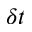<formula> <loc_0><loc_0><loc_500><loc_500>\delta t</formula> 